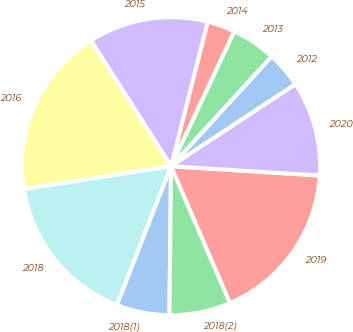Convert chart. <chart><loc_0><loc_0><loc_500><loc_500><pie_chart><fcel>2012<fcel>2013<fcel>2014<fcel>2015<fcel>2016<fcel>2018<fcel>2018(1)<fcel>2018(2)<fcel>2019<fcel>2020<nl><fcel>3.93%<fcel>4.83%<fcel>3.02%<fcel>12.99%<fcel>18.43%<fcel>16.62%<fcel>5.74%<fcel>6.65%<fcel>17.52%<fcel>10.27%<nl></chart> 